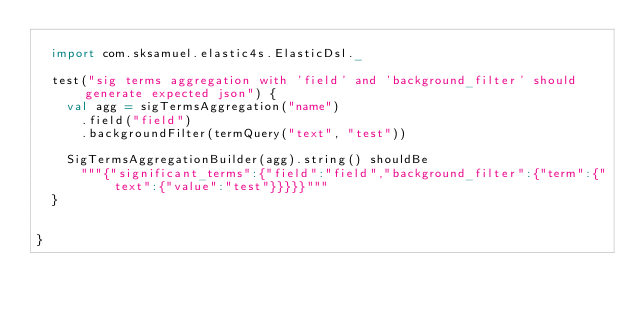<code> <loc_0><loc_0><loc_500><loc_500><_Scala_>
  import com.sksamuel.elastic4s.ElasticDsl._

  test("sig terms aggregation with 'field' and 'background_filter' should generate expected json") {
    val agg = sigTermsAggregation("name")
      .field("field")
      .backgroundFilter(termQuery("text", "test"))

    SigTermsAggregationBuilder(agg).string() shouldBe
      """{"significant_terms":{"field":"field","background_filter":{"term":{"text":{"value":"test"}}}}}"""
  }


}
</code> 